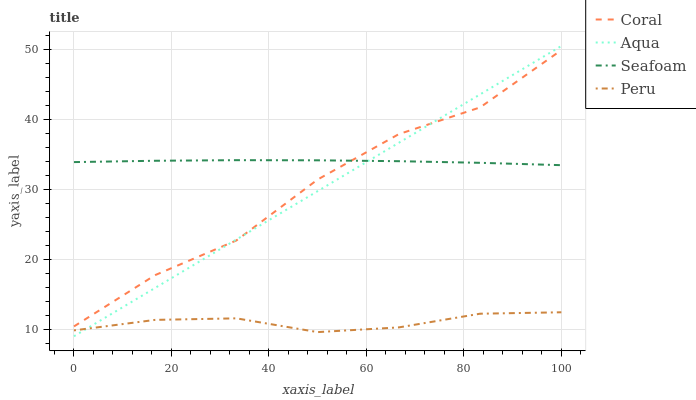Does Peru have the minimum area under the curve?
Answer yes or no. Yes. Does Seafoam have the maximum area under the curve?
Answer yes or no. Yes. Does Aqua have the minimum area under the curve?
Answer yes or no. No. Does Aqua have the maximum area under the curve?
Answer yes or no. No. Is Aqua the smoothest?
Answer yes or no. Yes. Is Coral the roughest?
Answer yes or no. Yes. Is Seafoam the smoothest?
Answer yes or no. No. Is Seafoam the roughest?
Answer yes or no. No. Does Aqua have the lowest value?
Answer yes or no. Yes. Does Seafoam have the lowest value?
Answer yes or no. No. Does Aqua have the highest value?
Answer yes or no. Yes. Does Seafoam have the highest value?
Answer yes or no. No. Is Peru less than Seafoam?
Answer yes or no. Yes. Is Seafoam greater than Peru?
Answer yes or no. Yes. Does Aqua intersect Peru?
Answer yes or no. Yes. Is Aqua less than Peru?
Answer yes or no. No. Is Aqua greater than Peru?
Answer yes or no. No. Does Peru intersect Seafoam?
Answer yes or no. No. 